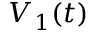Convert formula to latex. <formula><loc_0><loc_0><loc_500><loc_500>V _ { 1 } ( t )</formula> 